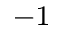<formula> <loc_0><loc_0><loc_500><loc_500>^ { - 1 }</formula> 